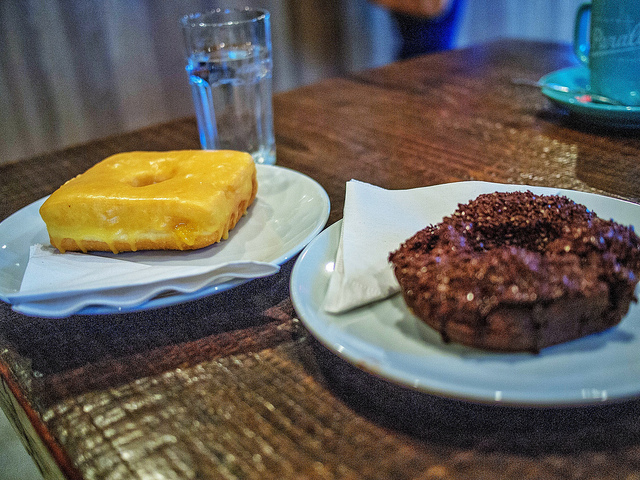Can you tell me more about the specific type of donuts shown? Of course, the donut on the left appears to be a classic glazed donut with a soft, chewy texture and a sweet, sugary glaze. The one on the right looks like a chocolate cake donut, dense and rich, topped with chocolate sprinkles which add a nice crunch. 